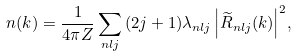<formula> <loc_0><loc_0><loc_500><loc_500>n ( k ) = \frac { 1 } { 4 \pi Z } \sum _ { n l j } { ( 2 j + 1 ) \lambda _ { n l j } \left | \widetilde { R } _ { n l j } ( k ) \right | ^ { 2 } } ,</formula> 